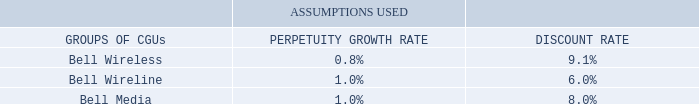IMPAIRMENT TESTING
As described in Note 2, Significant accounting policies, goodwill is tested annually for impairment by comparing the carrying value of a CGU or group of CGUs to the recoverable amount, where the recoverable amount is the higher of fair value less costs of disposal or value in use.
VALUE IN USE
The value in use for a CGU or group of CGUs is determined by discounting five-year cash flow projections derived from business plans reviewed by senior management. The projections reflect management’s expectations of revenue, segment profit, capital expenditures, working capital and operating cash flows, based on past experience and future expectations of operating performance.
Cash flows beyond the five-year period are extrapolated using perpetuity growth rates. None of the perpetuity growth rates exceed the long-term historical growth rates for the markets in which we operate.
The discount rates are applied to the cash flow projections and are derived from the weighted average cost of capital for each CGU or group of CGUs.
The following table shows the key assumptions used to estimate the recoverable amounts of the groups of CGUs.
The recoverable amounts determined in a prior year for the Bell Wireless and Bell Wireline groups of CGUs exceed their corresponding current carrying values by a substantial margin and have been carried forward and used in the impairment test for the current year. We believe that any reasonable possible change in the key assumptions on which the estimate of recoverable amounts of the Bell Wireless or Bell Wireline groups of CGUs is based would not cause their carrying amounts to exceed their recoverable amounts.
For the Bell Media group of CGUs, a decrease of (1.1%) in the perpetuity growth rate or an increase of 0.8% in the discount rate would have resulted in its recoverable amount being equal to its carrying value.
How is goodwill tested annually for impairment? By comparing the carrying value of a cgu or group of cgus to the recoverable amount, where the recoverable amount is the higher of fair value less costs of disposal or value in use. What do the five-year cash flow projections derived from business plans reflect? Management’s expectations of revenue, segment profit, capital expenditures, working capital and operating cash flows, based on past experience and future expectations of operating performance. What is the percentage for Bell Wireless when discount rate assumption is used? 9.1%. How many components are there under the groups of CGUs? Bell Wireless##Bell Wireline##Bell Media
Answer: 3. What is the difference in the perpetuity growth rate between Bell Wireless and Bell Wireline?
Answer scale should be: percent. 1.0%-0.8%
Answer: 0.2. What is the difference in the discount rate between Bell Wireline and Bell Media?
Answer scale should be: percent. 8.0%-6.0%
Answer: 2. 